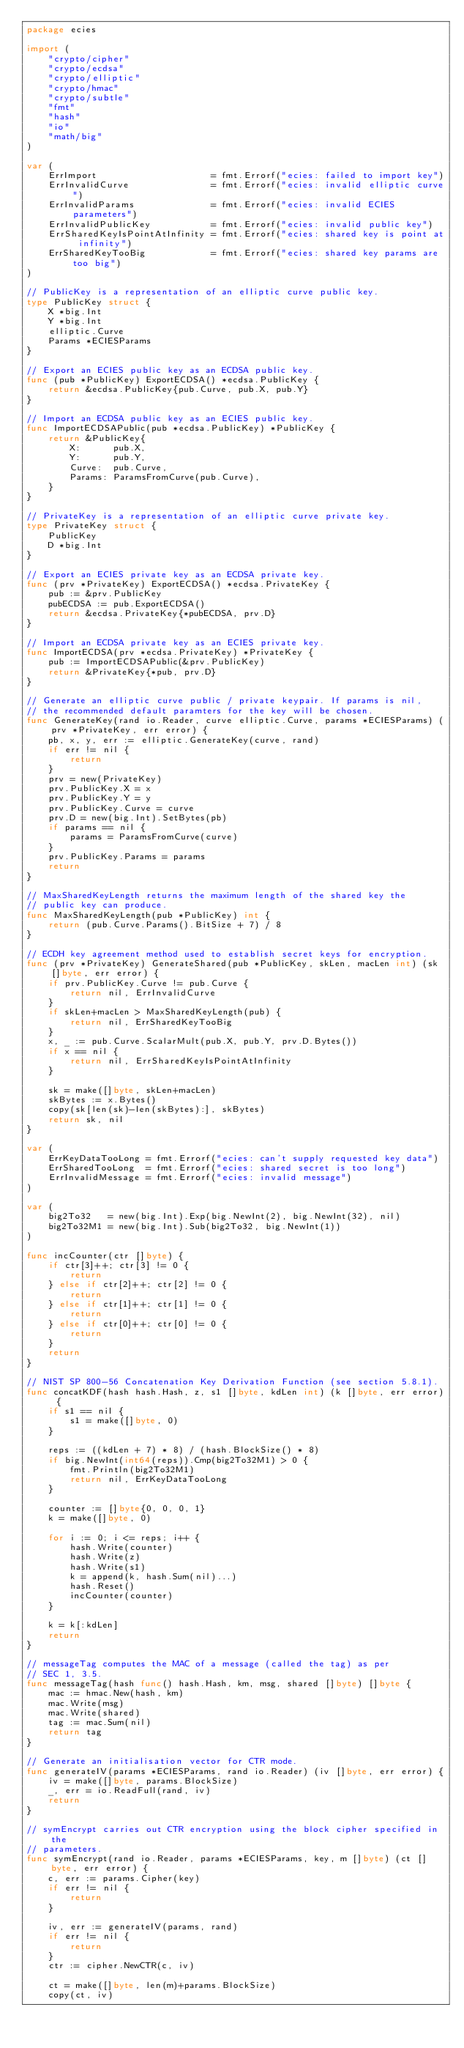Convert code to text. <code><loc_0><loc_0><loc_500><loc_500><_Go_>package ecies

import (
	"crypto/cipher"
	"crypto/ecdsa"
	"crypto/elliptic"
	"crypto/hmac"
	"crypto/subtle"
	"fmt"
	"hash"
	"io"
	"math/big"
)

var (
	ErrImport                     = fmt.Errorf("ecies: failed to import key")
	ErrInvalidCurve               = fmt.Errorf("ecies: invalid elliptic curve")
	ErrInvalidParams              = fmt.Errorf("ecies: invalid ECIES parameters")
	ErrInvalidPublicKey           = fmt.Errorf("ecies: invalid public key")
	ErrSharedKeyIsPointAtInfinity = fmt.Errorf("ecies: shared key is point at infinity")
	ErrSharedKeyTooBig            = fmt.Errorf("ecies: shared key params are too big")
)

// PublicKey is a representation of an elliptic curve public key.
type PublicKey struct {
	X *big.Int
	Y *big.Int
	elliptic.Curve
	Params *ECIESParams
}

// Export an ECIES public key as an ECDSA public key.
func (pub *PublicKey) ExportECDSA() *ecdsa.PublicKey {
	return &ecdsa.PublicKey{pub.Curve, pub.X, pub.Y}
}

// Import an ECDSA public key as an ECIES public key.
func ImportECDSAPublic(pub *ecdsa.PublicKey) *PublicKey {
	return &PublicKey{
		X:      pub.X,
		Y:      pub.Y,
		Curve:  pub.Curve,
		Params: ParamsFromCurve(pub.Curve),
	}
}

// PrivateKey is a representation of an elliptic curve private key.
type PrivateKey struct {
	PublicKey
	D *big.Int
}

// Export an ECIES private key as an ECDSA private key.
func (prv *PrivateKey) ExportECDSA() *ecdsa.PrivateKey {
	pub := &prv.PublicKey
	pubECDSA := pub.ExportECDSA()
	return &ecdsa.PrivateKey{*pubECDSA, prv.D}
}

// Import an ECDSA private key as an ECIES private key.
func ImportECDSA(prv *ecdsa.PrivateKey) *PrivateKey {
	pub := ImportECDSAPublic(&prv.PublicKey)
	return &PrivateKey{*pub, prv.D}
}

// Generate an elliptic curve public / private keypair. If params is nil,
// the recommended default paramters for the key will be chosen.
func GenerateKey(rand io.Reader, curve elliptic.Curve, params *ECIESParams) (prv *PrivateKey, err error) {
	pb, x, y, err := elliptic.GenerateKey(curve, rand)
	if err != nil {
		return
	}
	prv = new(PrivateKey)
	prv.PublicKey.X = x
	prv.PublicKey.Y = y
	prv.PublicKey.Curve = curve
	prv.D = new(big.Int).SetBytes(pb)
	if params == nil {
		params = ParamsFromCurve(curve)
	}
	prv.PublicKey.Params = params
	return
}

// MaxSharedKeyLength returns the maximum length of the shared key the
// public key can produce.
func MaxSharedKeyLength(pub *PublicKey) int {
	return (pub.Curve.Params().BitSize + 7) / 8
}

// ECDH key agreement method used to establish secret keys for encryption.
func (prv *PrivateKey) GenerateShared(pub *PublicKey, skLen, macLen int) (sk []byte, err error) {
	if prv.PublicKey.Curve != pub.Curve {
		return nil, ErrInvalidCurve
	}
	if skLen+macLen > MaxSharedKeyLength(pub) {
		return nil, ErrSharedKeyTooBig
	}
	x, _ := pub.Curve.ScalarMult(pub.X, pub.Y, prv.D.Bytes())
	if x == nil {
		return nil, ErrSharedKeyIsPointAtInfinity
	}

	sk = make([]byte, skLen+macLen)
	skBytes := x.Bytes()
	copy(sk[len(sk)-len(skBytes):], skBytes)
	return sk, nil
}

var (
	ErrKeyDataTooLong = fmt.Errorf("ecies: can't supply requested key data")
	ErrSharedTooLong  = fmt.Errorf("ecies: shared secret is too long")
	ErrInvalidMessage = fmt.Errorf("ecies: invalid message")
)

var (
	big2To32   = new(big.Int).Exp(big.NewInt(2), big.NewInt(32), nil)
	big2To32M1 = new(big.Int).Sub(big2To32, big.NewInt(1))
)

func incCounter(ctr []byte) {
	if ctr[3]++; ctr[3] != 0 {
		return
	} else if ctr[2]++; ctr[2] != 0 {
		return
	} else if ctr[1]++; ctr[1] != 0 {
		return
	} else if ctr[0]++; ctr[0] != 0 {
		return
	}
	return
}

// NIST SP 800-56 Concatenation Key Derivation Function (see section 5.8.1).
func concatKDF(hash hash.Hash, z, s1 []byte, kdLen int) (k []byte, err error) {
	if s1 == nil {
		s1 = make([]byte, 0)
	}

	reps := ((kdLen + 7) * 8) / (hash.BlockSize() * 8)
	if big.NewInt(int64(reps)).Cmp(big2To32M1) > 0 {
		fmt.Println(big2To32M1)
		return nil, ErrKeyDataTooLong
	}

	counter := []byte{0, 0, 0, 1}
	k = make([]byte, 0)

	for i := 0; i <= reps; i++ {
		hash.Write(counter)
		hash.Write(z)
		hash.Write(s1)
		k = append(k, hash.Sum(nil)...)
		hash.Reset()
		incCounter(counter)
	}

	k = k[:kdLen]
	return
}

// messageTag computes the MAC of a message (called the tag) as per
// SEC 1, 3.5.
func messageTag(hash func() hash.Hash, km, msg, shared []byte) []byte {
	mac := hmac.New(hash, km)
	mac.Write(msg)
	mac.Write(shared)
	tag := mac.Sum(nil)
	return tag
}

// Generate an initialisation vector for CTR mode.
func generateIV(params *ECIESParams, rand io.Reader) (iv []byte, err error) {
	iv = make([]byte, params.BlockSize)
	_, err = io.ReadFull(rand, iv)
	return
}

// symEncrypt carries out CTR encryption using the block cipher specified in the
// parameters.
func symEncrypt(rand io.Reader, params *ECIESParams, key, m []byte) (ct []byte, err error) {
	c, err := params.Cipher(key)
	if err != nil {
		return
	}

	iv, err := generateIV(params, rand)
	if err != nil {
		return
	}
	ctr := cipher.NewCTR(c, iv)

	ct = make([]byte, len(m)+params.BlockSize)
	copy(ct, iv)</code> 